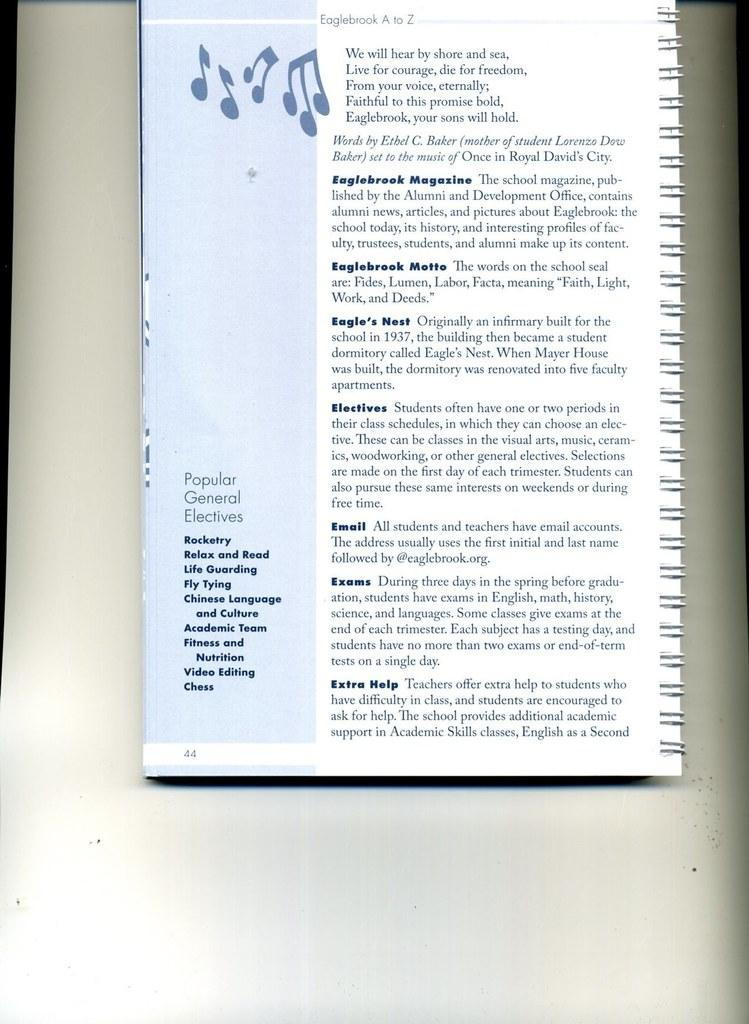Provide a one-sentence caption for the provided image. A musical book open to page 44 which is about popular general electives. 